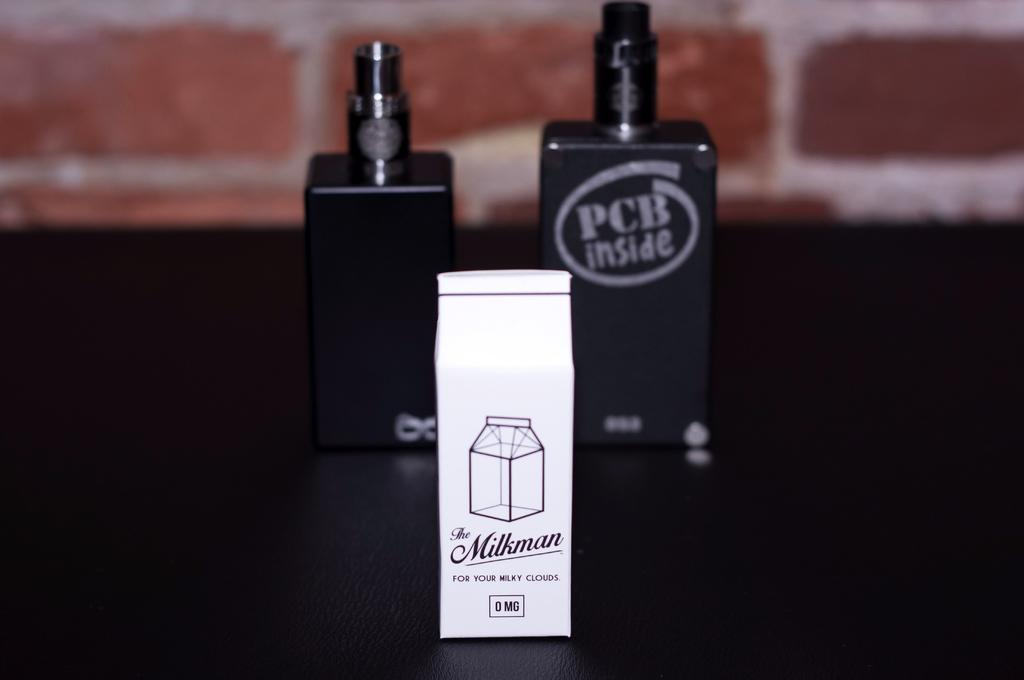<image>
Create a compact narrative representing the image presented. Two black spray bottles are sitting behind a white milk carton that says The Milkman. 